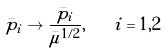Convert formula to latex. <formula><loc_0><loc_0><loc_500><loc_500>\bar { p } _ { i } \to \frac { \bar { p } _ { i } } { \bar { \mu } ^ { 1 / 2 } } , \quad i = 1 , 2</formula> 